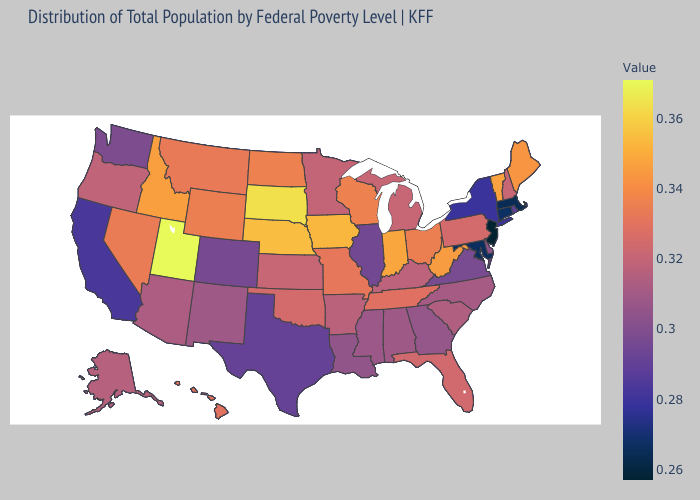Does New Hampshire have the highest value in the USA?
Quick response, please. No. Which states have the lowest value in the USA?
Write a very short answer. New Jersey. Does Nebraska have a higher value than Oregon?
Be succinct. Yes. Among the states that border Ohio , which have the lowest value?
Be succinct. Kentucky. Among the states that border Alabama , does Mississippi have the highest value?
Write a very short answer. No. Does Oregon have the lowest value in the USA?
Quick response, please. No. Which states have the lowest value in the South?
Be succinct. Maryland. 